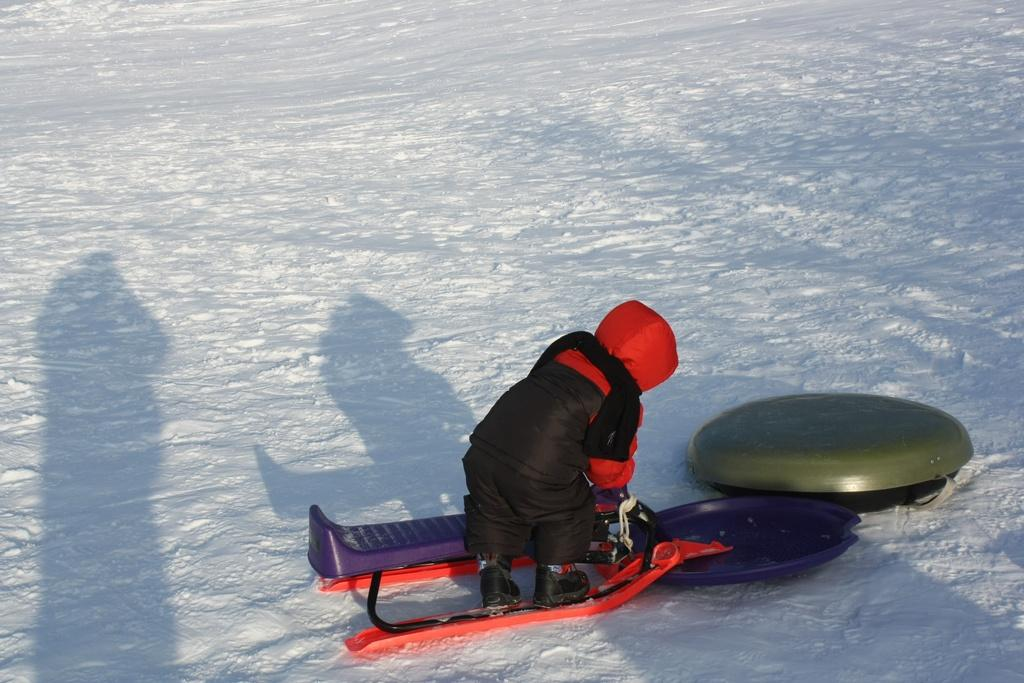What is the main subject in the foreground of the image? There is a person in the foreground of the image. What is the person holding in their hand? The person is holding an object in their hand. What can be seen on the road in the image? There are objects on the road in the image. What type of weather is depicted in the image? Snow is visible in the image. Can you determine the time of day the image was taken? The image was likely taken during the day, as there is sufficient light to see the details clearly. How many halls are visible in the image? There are no halls visible in the image; it features a person holding an object in their hand, objects on the road, and snow. What type of garden can be seen in the image? There is no garden present in the image. 